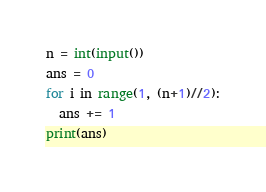<code> <loc_0><loc_0><loc_500><loc_500><_Python_>n = int(input())
ans = 0
for i in range(1, (n+1)//2):
  ans += 1
print(ans)</code> 